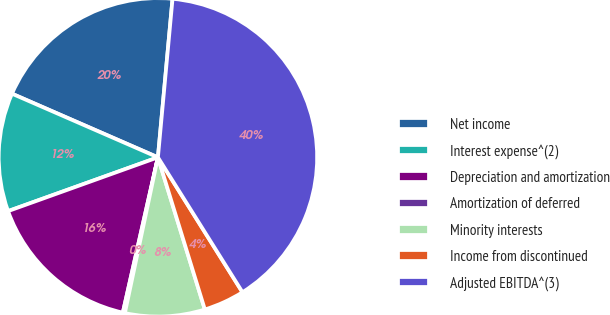Convert chart to OTSL. <chart><loc_0><loc_0><loc_500><loc_500><pie_chart><fcel>Net income<fcel>Interest expense^(2)<fcel>Depreciation and amortization<fcel>Amortization of deferred<fcel>Minority interests<fcel>Income from discontinued<fcel>Adjusted EBITDA^(3)<nl><fcel>19.92%<fcel>12.03%<fcel>15.98%<fcel>0.21%<fcel>8.09%<fcel>4.15%<fcel>39.63%<nl></chart> 